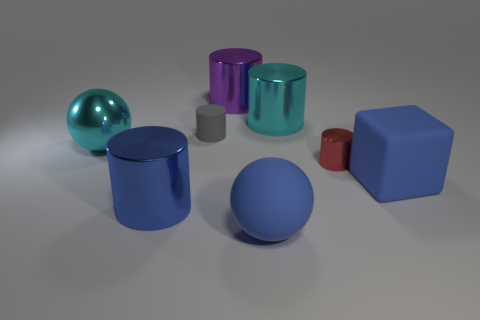What number of other big blocks have the same material as the block?
Provide a succinct answer. 0. Is the number of cyan metal cylinders that are on the left side of the cyan ball less than the number of large blue matte blocks?
Keep it short and to the point. Yes. There is a matte object behind the tiny cylinder in front of the tiny gray rubber cylinder; what size is it?
Make the answer very short. Small. Is the color of the large shiny ball the same as the large metallic object that is on the right side of the purple metal cylinder?
Ensure brevity in your answer.  Yes. There is a block that is the same size as the blue metallic object; what is its material?
Offer a very short reply. Rubber. Are there fewer big cyan shiny things in front of the matte ball than big purple cylinders on the right side of the blue shiny cylinder?
Offer a very short reply. Yes. What shape is the large blue object that is behind the big cylinder that is in front of the rubber cube?
Provide a succinct answer. Cube. Are there any gray shiny blocks?
Keep it short and to the point. No. The large metallic cylinder that is in front of the tiny gray thing is what color?
Keep it short and to the point. Blue. There is a large cylinder that is the same color as the large metal ball; what is it made of?
Offer a terse response. Metal. 